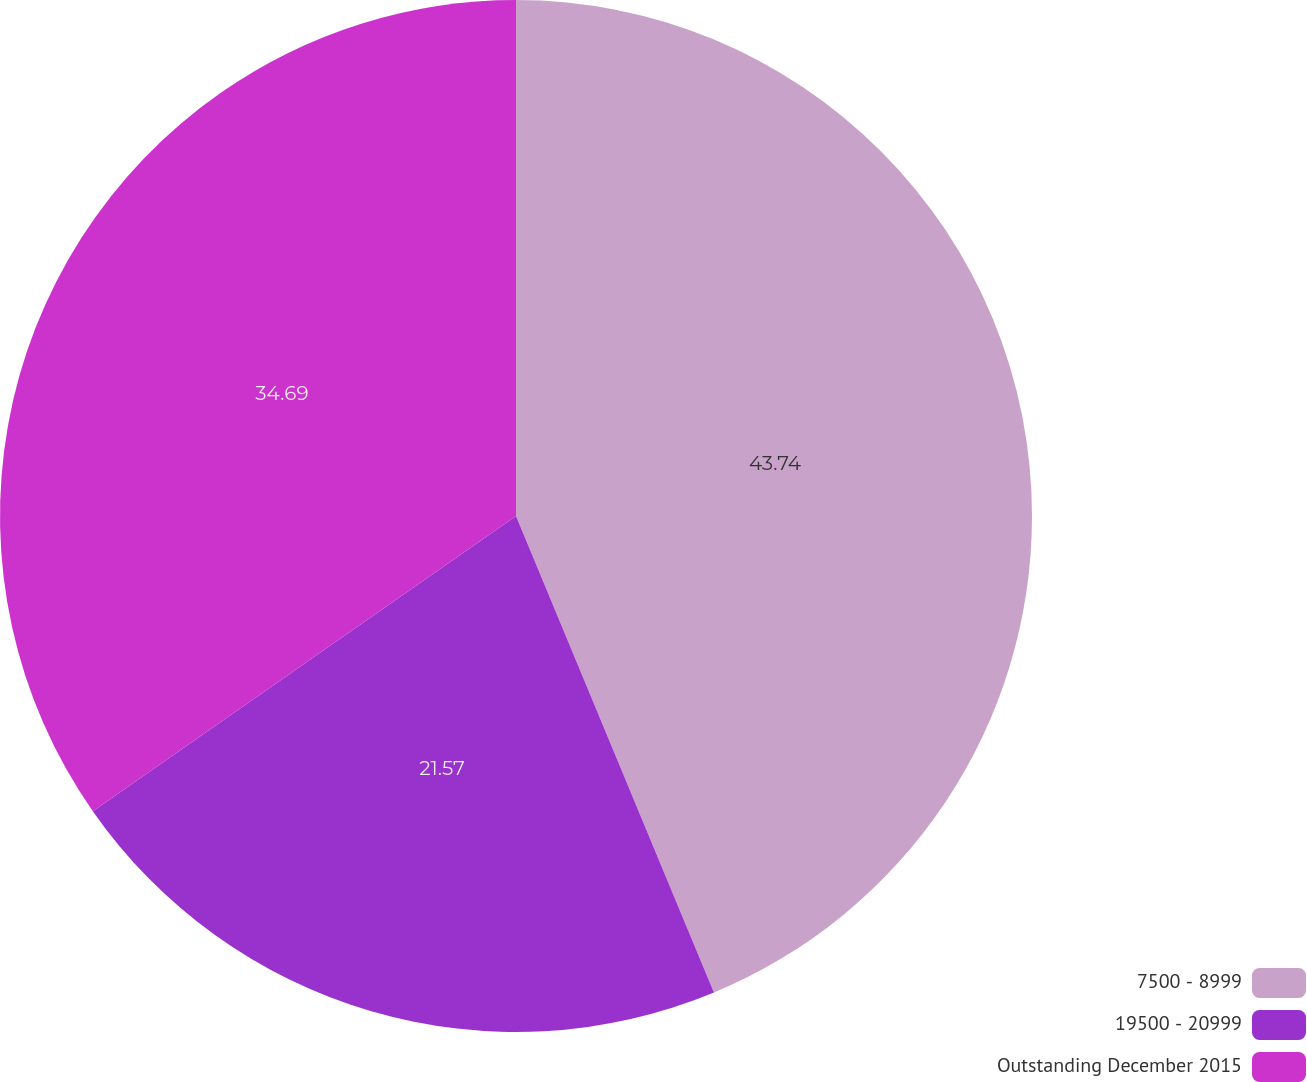Convert chart. <chart><loc_0><loc_0><loc_500><loc_500><pie_chart><fcel>7500 - 8999<fcel>19500 - 20999<fcel>Outstanding December 2015<nl><fcel>43.73%<fcel>21.57%<fcel>34.69%<nl></chart> 